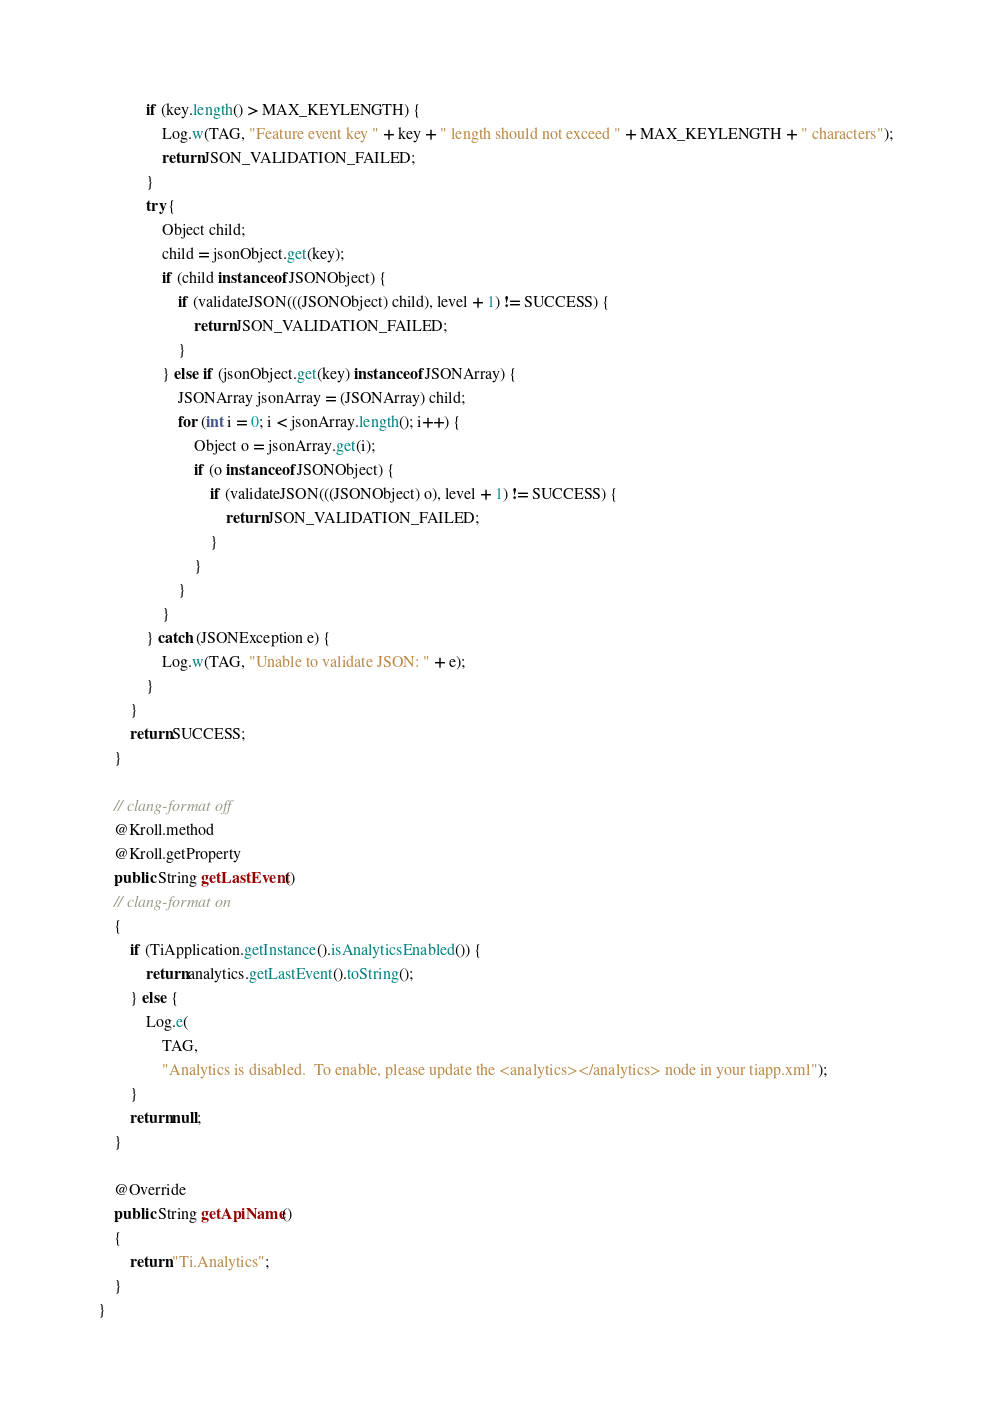<code> <loc_0><loc_0><loc_500><loc_500><_Java_>			if (key.length() > MAX_KEYLENGTH) {
				Log.w(TAG, "Feature event key " + key + " length should not exceed " + MAX_KEYLENGTH + " characters");
				return JSON_VALIDATION_FAILED;
			}
			try {
				Object child;
				child = jsonObject.get(key);
				if (child instanceof JSONObject) {
					if (validateJSON(((JSONObject) child), level + 1) != SUCCESS) {
						return JSON_VALIDATION_FAILED;
					}
				} else if (jsonObject.get(key) instanceof JSONArray) {
					JSONArray jsonArray = (JSONArray) child;
					for (int i = 0; i < jsonArray.length(); i++) {
						Object o = jsonArray.get(i);
						if (o instanceof JSONObject) {
							if (validateJSON(((JSONObject) o), level + 1) != SUCCESS) {
								return JSON_VALIDATION_FAILED;
							}
						}
					}
				}
			} catch (JSONException e) {
				Log.w(TAG, "Unable to validate JSON: " + e);
			}
		}
		return SUCCESS;
	}

	// clang-format off
	@Kroll.method
	@Kroll.getProperty
	public String getLastEvent()
	// clang-format on
	{
		if (TiApplication.getInstance().isAnalyticsEnabled()) {
			return analytics.getLastEvent().toString();
		} else {
			Log.e(
				TAG,
				"Analytics is disabled.  To enable, please update the <analytics></analytics> node in your tiapp.xml");
		}
		return null;
	}

	@Override
	public String getApiName()
	{
		return "Ti.Analytics";
	}
}
</code> 